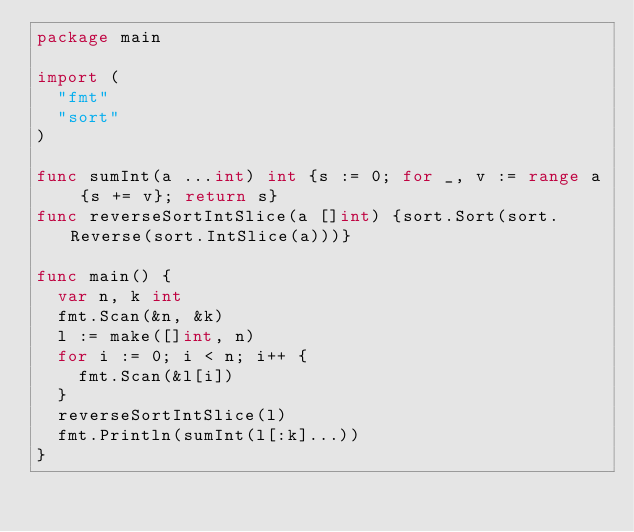<code> <loc_0><loc_0><loc_500><loc_500><_Go_>package main

import (
  "fmt"
  "sort"
)

func sumInt(a ...int) int {s := 0; for _, v := range a {s += v}; return s}
func reverseSortIntSlice(a []int) {sort.Sort(sort.Reverse(sort.IntSlice(a)))}

func main() {
  var n, k int 
  fmt.Scan(&n, &k)
  l := make([]int, n)
  for i := 0; i < n; i++ {
    fmt.Scan(&l[i])
  }
  reverseSortIntSlice(l)
  fmt.Println(sumInt(l[:k]...))
}</code> 